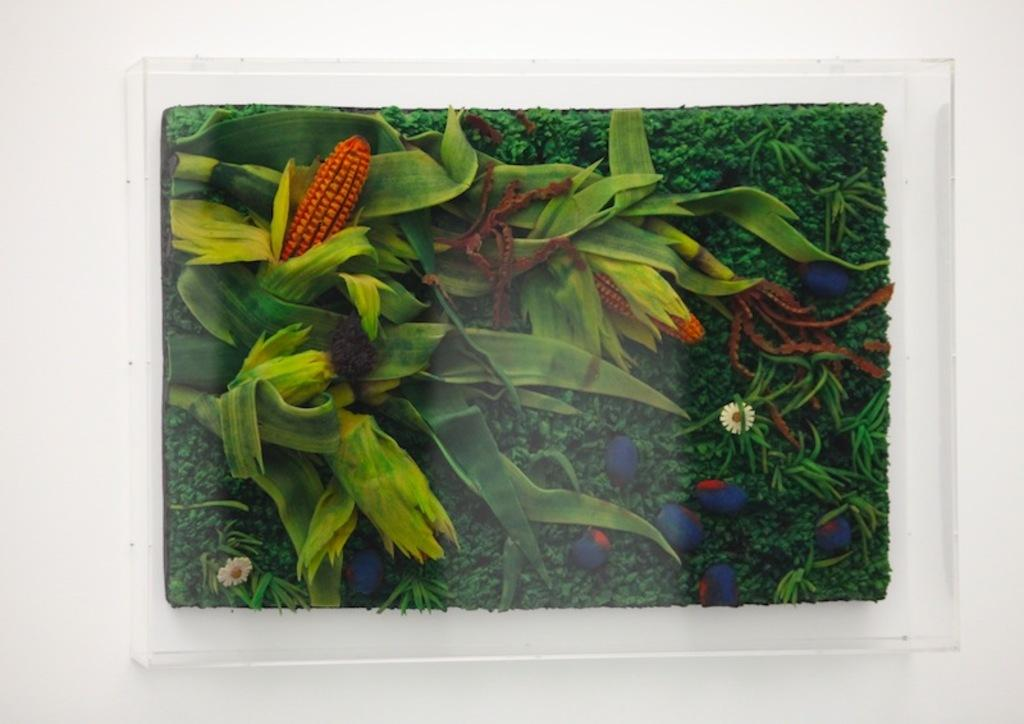What is the main subject of the image? There is a painting in the image. Where is the painting located? The painting is placed on a wall. What elements are depicted in the painting? The painting contains plants, pebbles, fruits, and flowers. What type of pizzas can be seen in the painting? There are no pizzas present in the painting; it contains plants, pebbles, fruits, and flowers. 